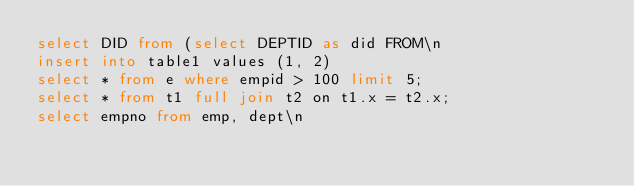<code> <loc_0><loc_0><loc_500><loc_500><_SQL_>select DID from (select DEPTID as did FROM\n
insert into table1 values (1, 2)
select * from e where empid > 100 limit 5;
select * from t1 full join t2 on t1.x = t2.x;
select empno from emp, dept\n</code> 